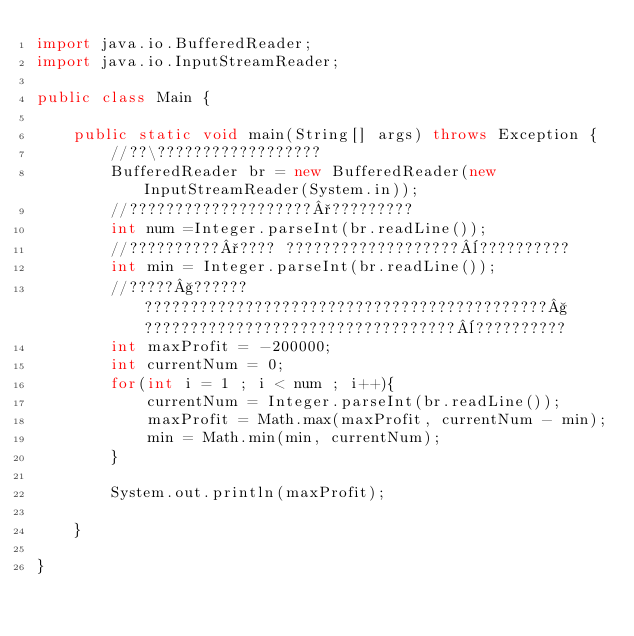Convert code to text. <code><loc_0><loc_0><loc_500><loc_500><_Java_>import java.io.BufferedReader;
import java.io.InputStreamReader;

public class Main {

	public static void main(String[] args) throws Exception {
		//??\??????????????????
        BufferedReader br = new BufferedReader(new InputStreamReader(System.in));
        //????????????????????°?????????
        int num =Integer.parseInt(br.readLine());
        //??????????°???? ???????????????????¨??????????
        int min = Integer.parseInt(br.readLine());
        //?????§?????? ????????????????????????????????????????????§??????????????????????????????????¨??????????
        int maxProfit = -200000;
        int currentNum = 0;
        for(int i = 1 ; i < num ; i++){
        	currentNum = Integer.parseInt(br.readLine());
        	maxProfit = Math.max(maxProfit, currentNum - min);
        	min = Math.min(min, currentNum);
        }
        
        System.out.println(maxProfit);

	}

}</code> 